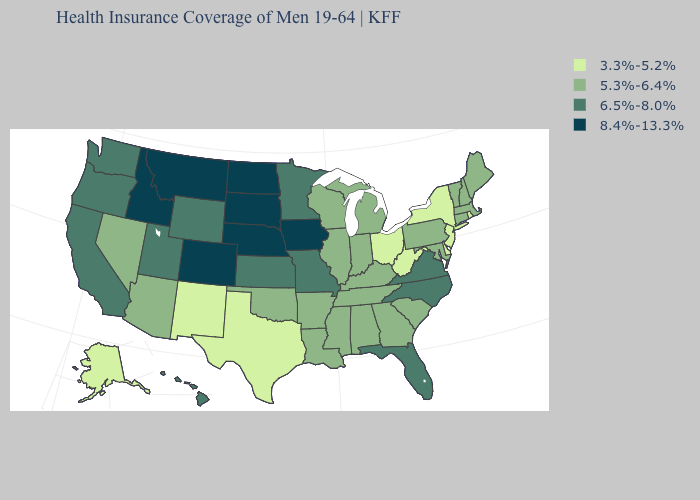Which states have the lowest value in the USA?
Keep it brief. Alaska, Delaware, New Jersey, New Mexico, New York, Ohio, Rhode Island, Texas, West Virginia. Name the states that have a value in the range 8.4%-13.3%?
Concise answer only. Colorado, Idaho, Iowa, Montana, Nebraska, North Dakota, South Dakota. What is the value of Kentucky?
Answer briefly. 5.3%-6.4%. Name the states that have a value in the range 3.3%-5.2%?
Keep it brief. Alaska, Delaware, New Jersey, New Mexico, New York, Ohio, Rhode Island, Texas, West Virginia. Does Idaho have the lowest value in the West?
Be succinct. No. Does New York have the highest value in the USA?
Keep it brief. No. Name the states that have a value in the range 3.3%-5.2%?
Concise answer only. Alaska, Delaware, New Jersey, New Mexico, New York, Ohio, Rhode Island, Texas, West Virginia. Is the legend a continuous bar?
Write a very short answer. No. Name the states that have a value in the range 8.4%-13.3%?
Give a very brief answer. Colorado, Idaho, Iowa, Montana, Nebraska, North Dakota, South Dakota. What is the value of Louisiana?
Short answer required. 5.3%-6.4%. Name the states that have a value in the range 8.4%-13.3%?
Write a very short answer. Colorado, Idaho, Iowa, Montana, Nebraska, North Dakota, South Dakota. Name the states that have a value in the range 5.3%-6.4%?
Answer briefly. Alabama, Arizona, Arkansas, Connecticut, Georgia, Illinois, Indiana, Kentucky, Louisiana, Maine, Maryland, Massachusetts, Michigan, Mississippi, Nevada, New Hampshire, Oklahoma, Pennsylvania, South Carolina, Tennessee, Vermont, Wisconsin. What is the value of North Carolina?
Answer briefly. 6.5%-8.0%. Does Connecticut have the lowest value in the Northeast?
Answer briefly. No. What is the value of Wisconsin?
Be succinct. 5.3%-6.4%. 